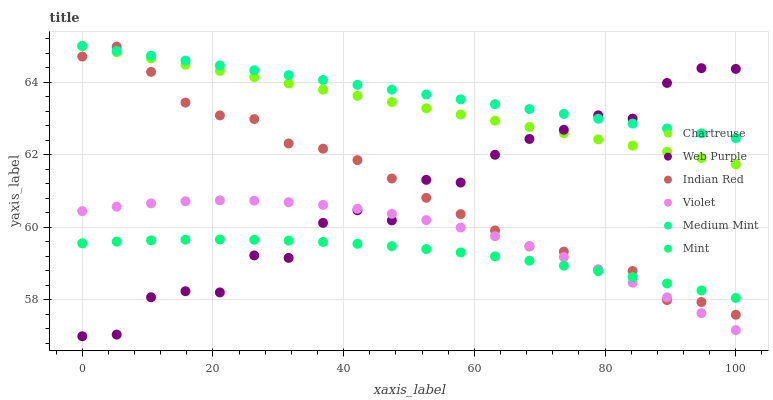Does Mint have the minimum area under the curve?
Answer yes or no. Yes. Does Medium Mint have the maximum area under the curve?
Answer yes or no. Yes. Does Web Purple have the minimum area under the curve?
Answer yes or no. No. Does Web Purple have the maximum area under the curve?
Answer yes or no. No. Is Medium Mint the smoothest?
Answer yes or no. Yes. Is Web Purple the roughest?
Answer yes or no. Yes. Is Chartreuse the smoothest?
Answer yes or no. No. Is Chartreuse the roughest?
Answer yes or no. No. Does Web Purple have the lowest value?
Answer yes or no. Yes. Does Chartreuse have the lowest value?
Answer yes or no. No. Does Chartreuse have the highest value?
Answer yes or no. Yes. Does Web Purple have the highest value?
Answer yes or no. No. Is Violet less than Chartreuse?
Answer yes or no. Yes. Is Medium Mint greater than Violet?
Answer yes or no. Yes. Does Indian Red intersect Mint?
Answer yes or no. Yes. Is Indian Red less than Mint?
Answer yes or no. No. Is Indian Red greater than Mint?
Answer yes or no. No. Does Violet intersect Chartreuse?
Answer yes or no. No. 